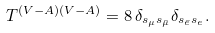<formula> <loc_0><loc_0><loc_500><loc_500>T ^ { ( V - A ) ( V - A ) } = 8 \, \delta _ { s _ { \mu } s _ { \bar { \mu } } } \delta _ { s _ { \bar { e } } s _ { e } } .</formula> 